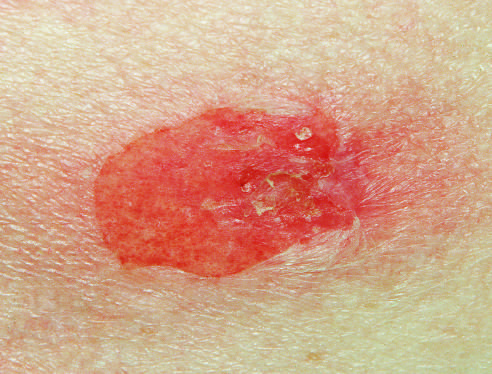s a typical blister, which is more superficial than those seen in pemphigus vulgaris shown?
Answer the question using a single word or phrase. Yes 